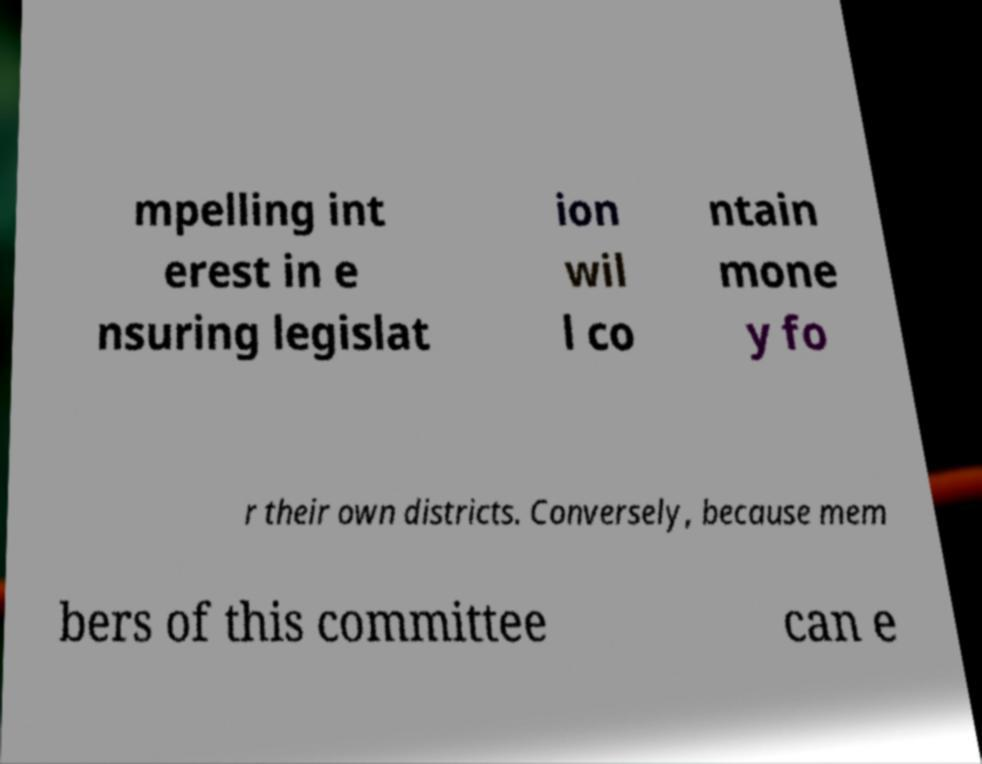Can you read and provide the text displayed in the image?This photo seems to have some interesting text. Can you extract and type it out for me? mpelling int erest in e nsuring legislat ion wil l co ntain mone y fo r their own districts. Conversely, because mem bers of this committee can e 